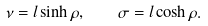<formula> <loc_0><loc_0><loc_500><loc_500>\nu = l \sinh \rho , \quad \sigma = l \cosh \rho .</formula> 